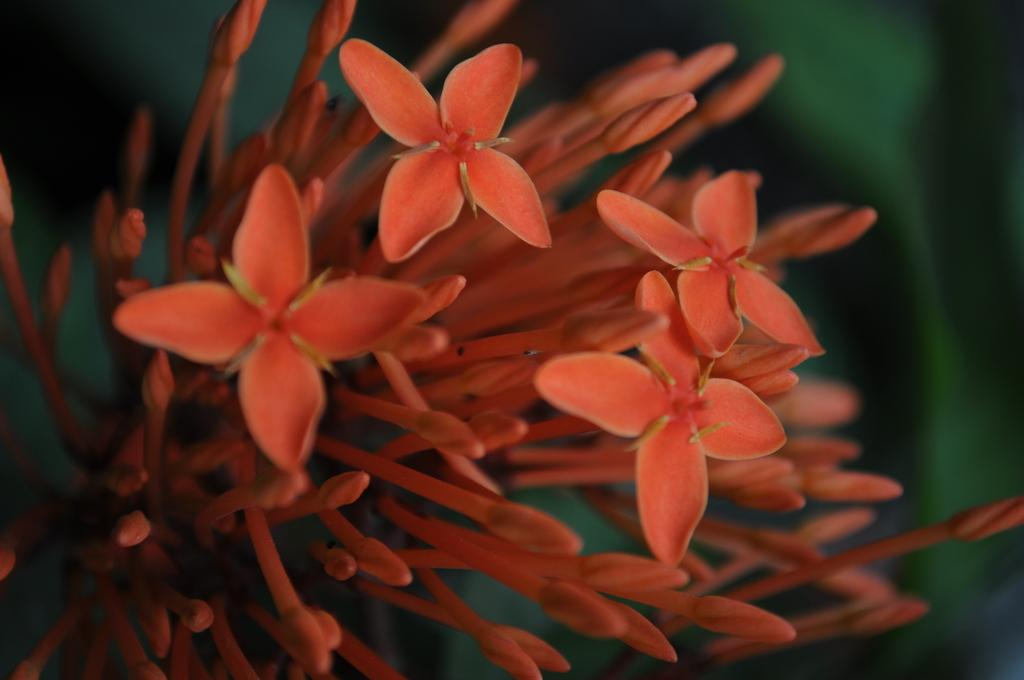What type of flower is present in the image? There is an orange flower in the image. What type of pollution is visible in the image? There is no pollution visible in the image; it only features an orange flower. How many daughters are present in the image? There are no people, let alone daughters, present in the image; it only features an orange flower. 